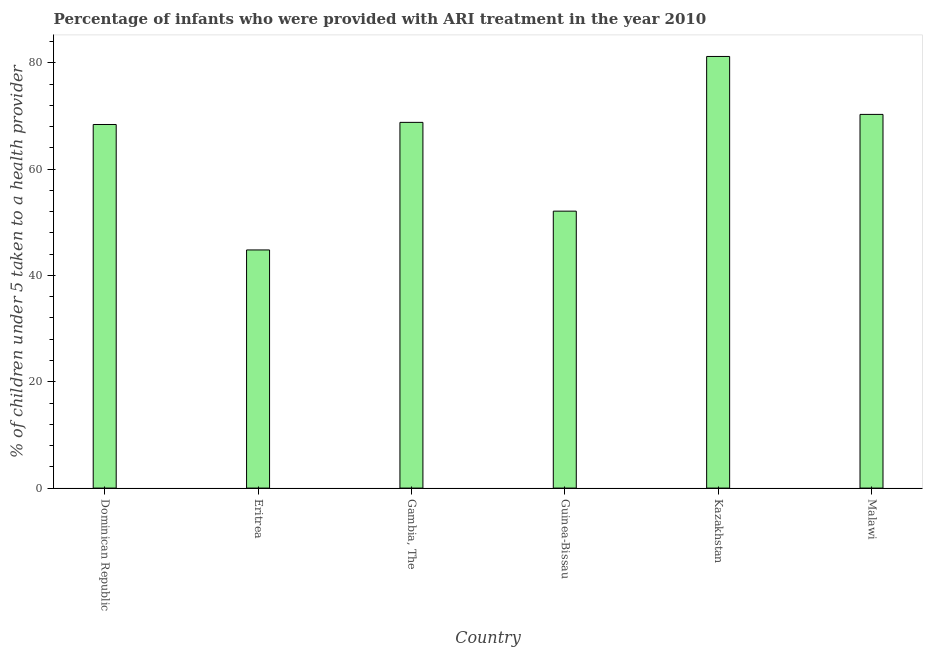What is the title of the graph?
Keep it short and to the point. Percentage of infants who were provided with ARI treatment in the year 2010. What is the label or title of the X-axis?
Provide a short and direct response. Country. What is the label or title of the Y-axis?
Ensure brevity in your answer.  % of children under 5 taken to a health provider. What is the percentage of children who were provided with ari treatment in Guinea-Bissau?
Ensure brevity in your answer.  52.1. Across all countries, what is the maximum percentage of children who were provided with ari treatment?
Your response must be concise. 81.2. Across all countries, what is the minimum percentage of children who were provided with ari treatment?
Your answer should be compact. 44.8. In which country was the percentage of children who were provided with ari treatment maximum?
Offer a very short reply. Kazakhstan. In which country was the percentage of children who were provided with ari treatment minimum?
Provide a succinct answer. Eritrea. What is the sum of the percentage of children who were provided with ari treatment?
Provide a succinct answer. 385.6. What is the average percentage of children who were provided with ari treatment per country?
Provide a short and direct response. 64.27. What is the median percentage of children who were provided with ari treatment?
Ensure brevity in your answer.  68.6. In how many countries, is the percentage of children who were provided with ari treatment greater than 80 %?
Ensure brevity in your answer.  1. What is the ratio of the percentage of children who were provided with ari treatment in Eritrea to that in Gambia, The?
Make the answer very short. 0.65. What is the difference between the highest and the second highest percentage of children who were provided with ari treatment?
Make the answer very short. 10.9. Is the sum of the percentage of children who were provided with ari treatment in Guinea-Bissau and Kazakhstan greater than the maximum percentage of children who were provided with ari treatment across all countries?
Keep it short and to the point. Yes. What is the difference between the highest and the lowest percentage of children who were provided with ari treatment?
Your response must be concise. 36.4. In how many countries, is the percentage of children who were provided with ari treatment greater than the average percentage of children who were provided with ari treatment taken over all countries?
Keep it short and to the point. 4. How many bars are there?
Offer a terse response. 6. Are all the bars in the graph horizontal?
Offer a very short reply. No. How many countries are there in the graph?
Provide a succinct answer. 6. What is the % of children under 5 taken to a health provider of Dominican Republic?
Your answer should be compact. 68.4. What is the % of children under 5 taken to a health provider in Eritrea?
Keep it short and to the point. 44.8. What is the % of children under 5 taken to a health provider of Gambia, The?
Give a very brief answer. 68.8. What is the % of children under 5 taken to a health provider in Guinea-Bissau?
Your answer should be very brief. 52.1. What is the % of children under 5 taken to a health provider in Kazakhstan?
Your answer should be compact. 81.2. What is the % of children under 5 taken to a health provider in Malawi?
Offer a very short reply. 70.3. What is the difference between the % of children under 5 taken to a health provider in Dominican Republic and Eritrea?
Keep it short and to the point. 23.6. What is the difference between the % of children under 5 taken to a health provider in Dominican Republic and Gambia, The?
Make the answer very short. -0.4. What is the difference between the % of children under 5 taken to a health provider in Dominican Republic and Guinea-Bissau?
Provide a succinct answer. 16.3. What is the difference between the % of children under 5 taken to a health provider in Dominican Republic and Malawi?
Provide a succinct answer. -1.9. What is the difference between the % of children under 5 taken to a health provider in Eritrea and Guinea-Bissau?
Your response must be concise. -7.3. What is the difference between the % of children under 5 taken to a health provider in Eritrea and Kazakhstan?
Your response must be concise. -36.4. What is the difference between the % of children under 5 taken to a health provider in Eritrea and Malawi?
Ensure brevity in your answer.  -25.5. What is the difference between the % of children under 5 taken to a health provider in Guinea-Bissau and Kazakhstan?
Provide a succinct answer. -29.1. What is the difference between the % of children under 5 taken to a health provider in Guinea-Bissau and Malawi?
Keep it short and to the point. -18.2. What is the ratio of the % of children under 5 taken to a health provider in Dominican Republic to that in Eritrea?
Offer a terse response. 1.53. What is the ratio of the % of children under 5 taken to a health provider in Dominican Republic to that in Guinea-Bissau?
Offer a very short reply. 1.31. What is the ratio of the % of children under 5 taken to a health provider in Dominican Republic to that in Kazakhstan?
Offer a very short reply. 0.84. What is the ratio of the % of children under 5 taken to a health provider in Eritrea to that in Gambia, The?
Ensure brevity in your answer.  0.65. What is the ratio of the % of children under 5 taken to a health provider in Eritrea to that in Guinea-Bissau?
Offer a very short reply. 0.86. What is the ratio of the % of children under 5 taken to a health provider in Eritrea to that in Kazakhstan?
Ensure brevity in your answer.  0.55. What is the ratio of the % of children under 5 taken to a health provider in Eritrea to that in Malawi?
Give a very brief answer. 0.64. What is the ratio of the % of children under 5 taken to a health provider in Gambia, The to that in Guinea-Bissau?
Offer a very short reply. 1.32. What is the ratio of the % of children under 5 taken to a health provider in Gambia, The to that in Kazakhstan?
Offer a terse response. 0.85. What is the ratio of the % of children under 5 taken to a health provider in Guinea-Bissau to that in Kazakhstan?
Your answer should be compact. 0.64. What is the ratio of the % of children under 5 taken to a health provider in Guinea-Bissau to that in Malawi?
Offer a terse response. 0.74. What is the ratio of the % of children under 5 taken to a health provider in Kazakhstan to that in Malawi?
Ensure brevity in your answer.  1.16. 